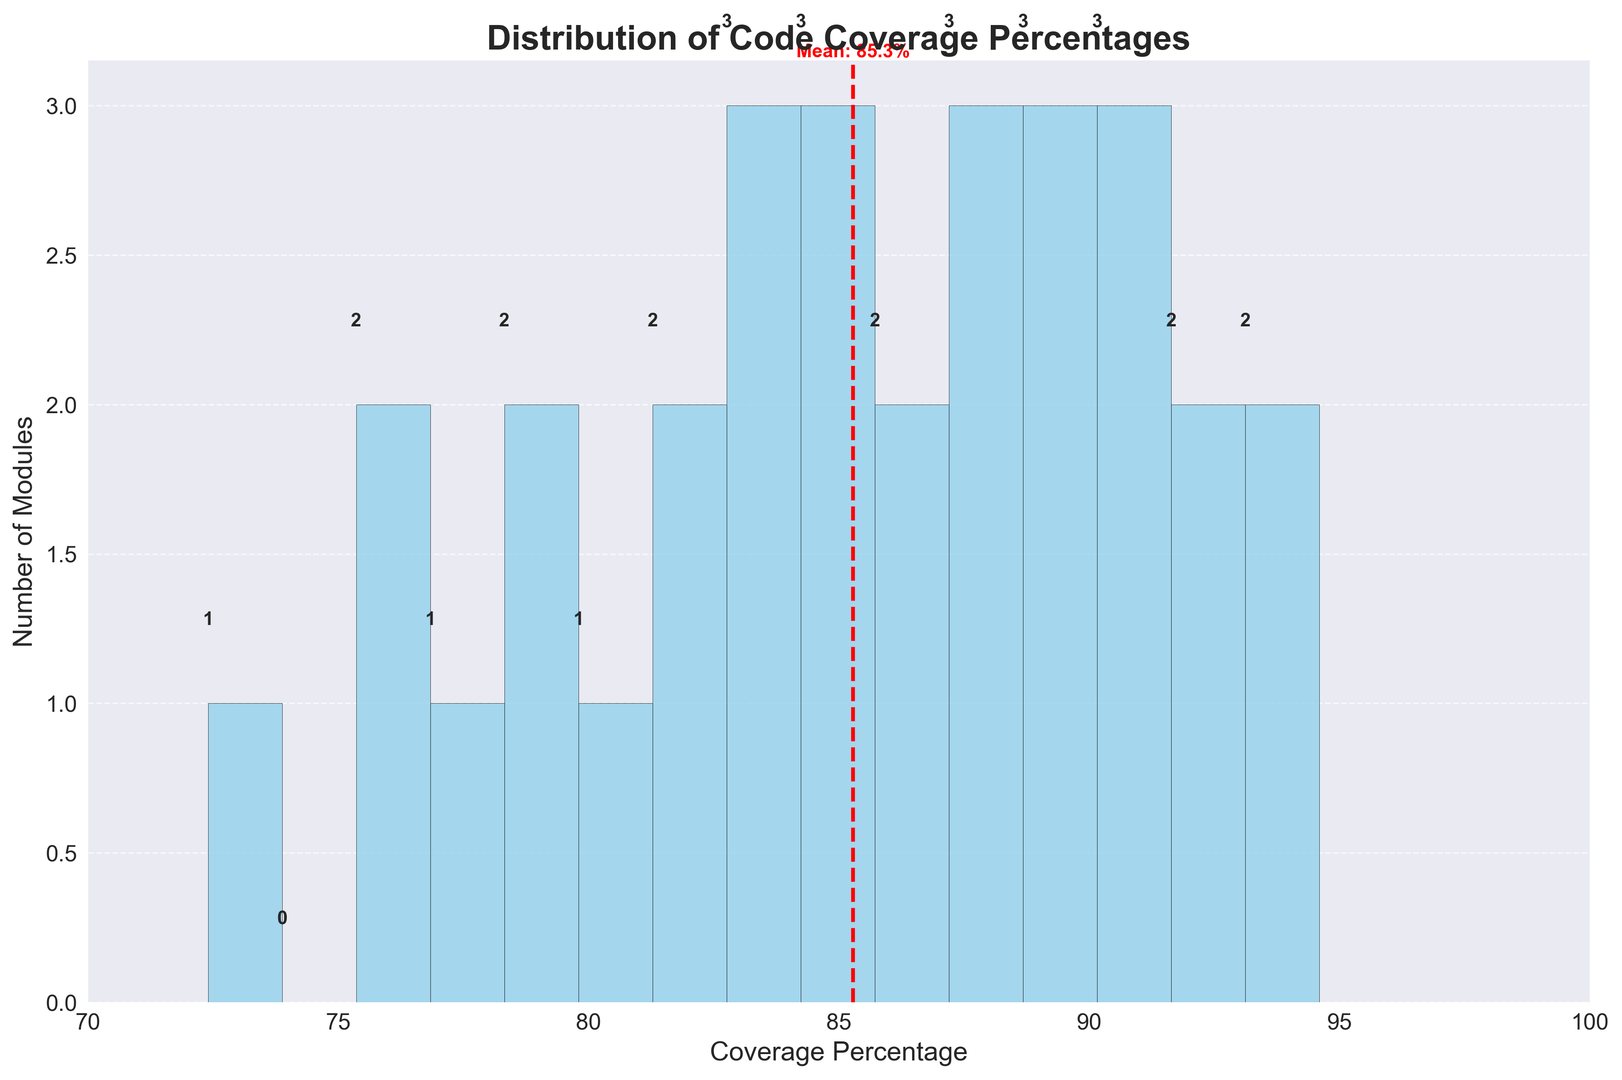What is the average code coverage percentage shown in the histogram? The red dashed line in the histogram represents the mean value of code coverage, which is labeled on the figure next to the line.
Answer: 85.8% Which module has the highest code coverage percentage? By looking at the x-axis, we can see the highest percentage at 94.6%, and this corresponds to the Testing module.
Answer: Testing How many modules have a code coverage percentage between 80% and 90%? By examining the height of the bars in the range of 80% to 90% on the x-axis, we can sum the number of modules represented by these bars.
Answer: 17 Is there any module with a code coverage percentage below 75%? From the histogram, we can see the lowest bin starts from 70% to 75%, and there is a bar in this bin which represents there is at least one module with coverage below 75%.
Answer: Yes Compare the number of modules with code coverage below 80% to those with coverage at or above 90%. We can count the number of modules represented by bars below the 80% mark and those above or equal to the 90% mark on the x-axis, then compare these counts.
Answer: Fewer below 80% Which bin has the maximum number of modules? The bin with the highest bar represents the maximum number of modules; we can read this from the histogram.
Answer: 80% - 85% What is the range of code coverage percentages in the dataset? The range can be derived from the visible extent of the x-axis, noting the minimum and maximum values shown.
Answer: 72.4% - 94.6% How many modules have a code coverage percentage above the mean? The mean is shown with a red dashed line on the histogram. We can count the bars to the right of this line to find the number of modules meeting this criterion.
Answer: 12 